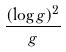<formula> <loc_0><loc_0><loc_500><loc_500>\frac { ( \log g ) ^ { 2 } } { g }</formula> 